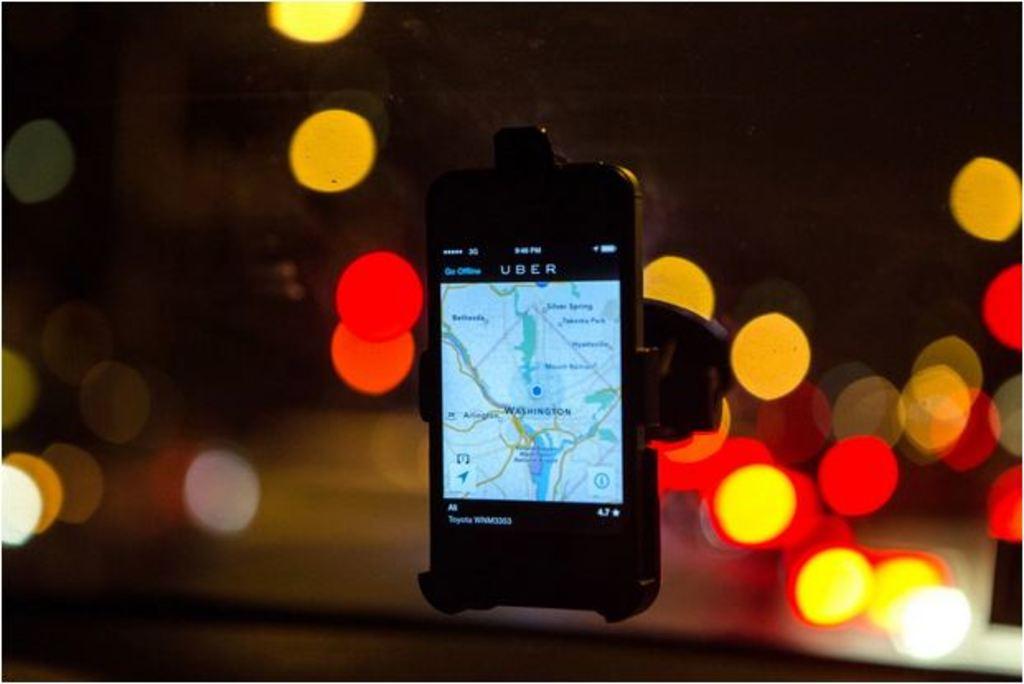What is the name of the city in big bold text?
Ensure brevity in your answer.  Washington. 